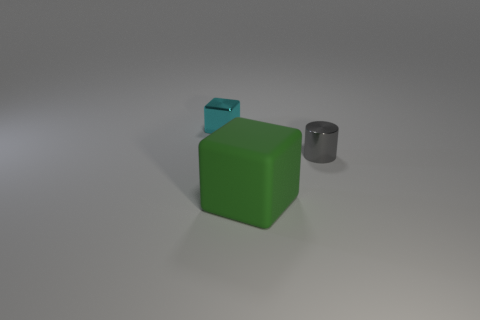Are there any other things that are the same material as the big block?
Your response must be concise. No. What number of tiny cyan things are there?
Your answer should be very brief. 1. How many other small cyan objects are the same shape as the cyan object?
Your answer should be very brief. 0. Do the small cyan metal object and the large matte thing have the same shape?
Keep it short and to the point. Yes. The cyan cube is what size?
Provide a short and direct response. Small. What number of gray cylinders are the same size as the cyan shiny cube?
Offer a terse response. 1. There is a cube that is behind the big rubber thing; does it have the same size as the thing right of the large rubber thing?
Make the answer very short. Yes. What shape is the tiny cyan object that is behind the green block?
Provide a succinct answer. Cube. The cube that is in front of the tiny object that is on the left side of the gray thing is made of what material?
Your answer should be very brief. Rubber. There is a metal cube; is its size the same as the metallic object to the right of the tiny cyan metal thing?
Offer a terse response. Yes. 